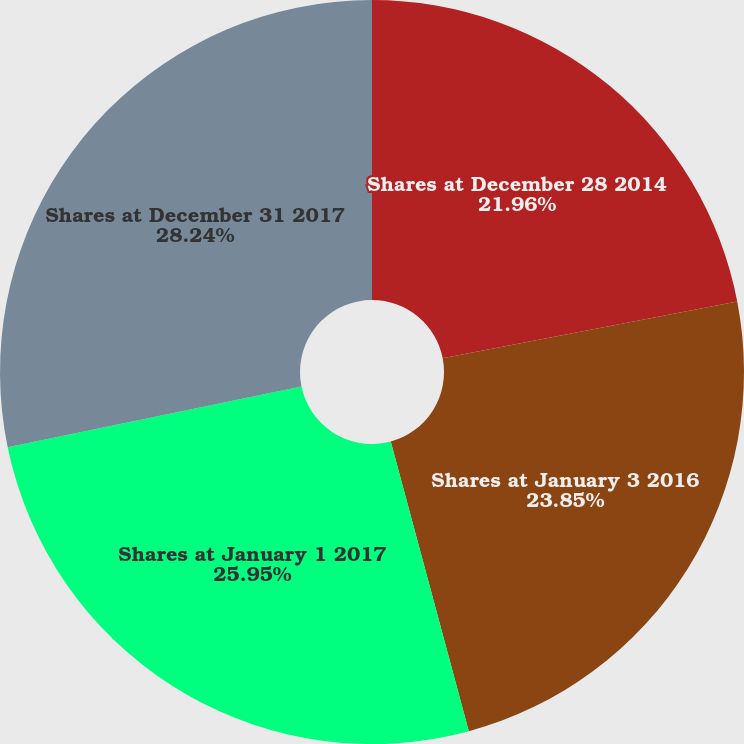<chart> <loc_0><loc_0><loc_500><loc_500><pie_chart><fcel>Shares at December 28 2014<fcel>Shares at January 3 2016<fcel>Shares at January 1 2017<fcel>Shares at December 31 2017<nl><fcel>21.96%<fcel>23.85%<fcel>25.95%<fcel>28.24%<nl></chart> 